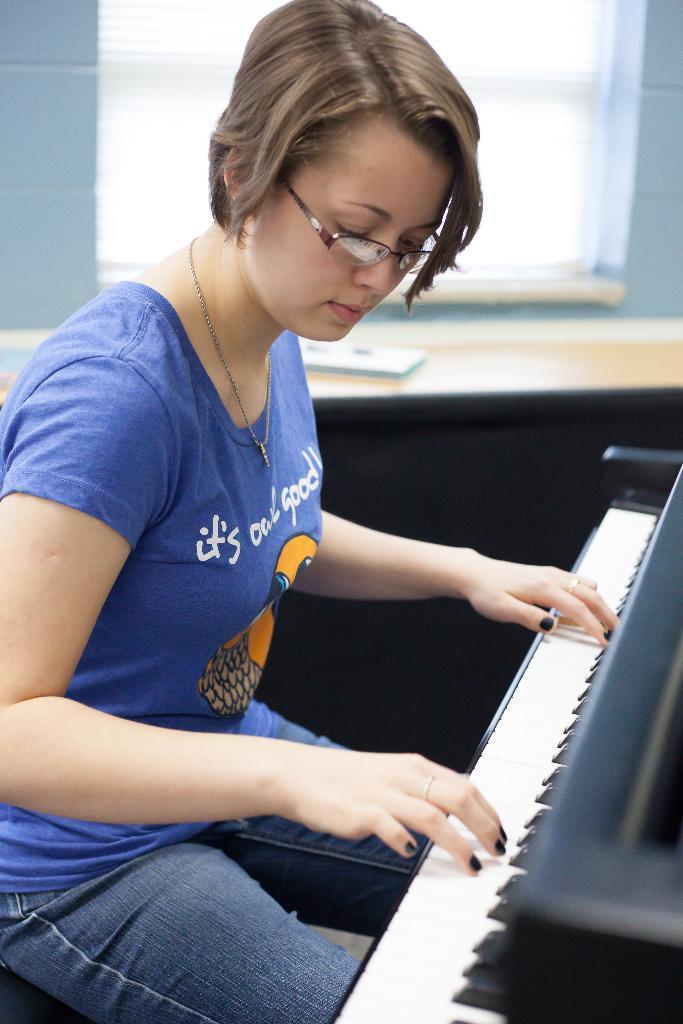How would you summarize this image in a sentence or two? She is sitting on a chair. She is playing a musical keyboard. We can see in background window. 